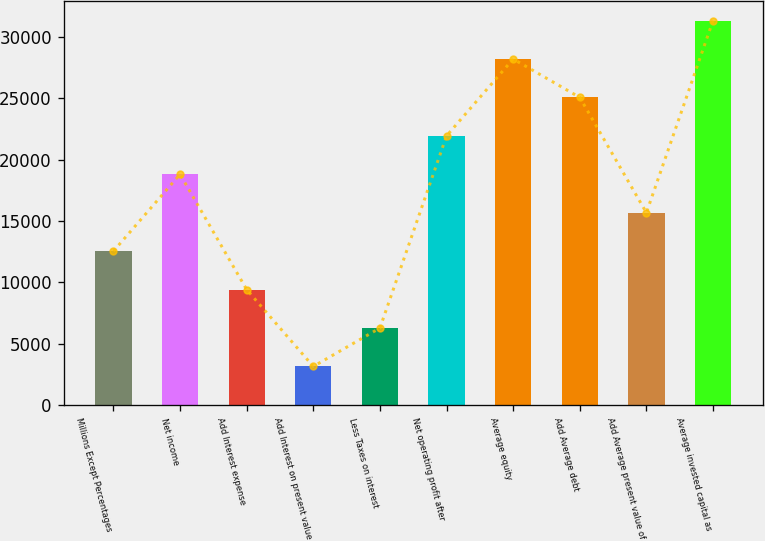<chart> <loc_0><loc_0><loc_500><loc_500><bar_chart><fcel>Millions Except Percentages<fcel>Net income<fcel>Add Interest expense<fcel>Add Interest on present value<fcel>Less Taxes on interest<fcel>Net operating profit after<fcel>Average equity<fcel>Add Average debt<fcel>Add Average present value of<fcel>Average invested capital as<nl><fcel>12544.4<fcel>18809.6<fcel>9411.8<fcel>3146.6<fcel>6279.2<fcel>21942.2<fcel>28207.4<fcel>25074.8<fcel>15677<fcel>31340<nl></chart> 